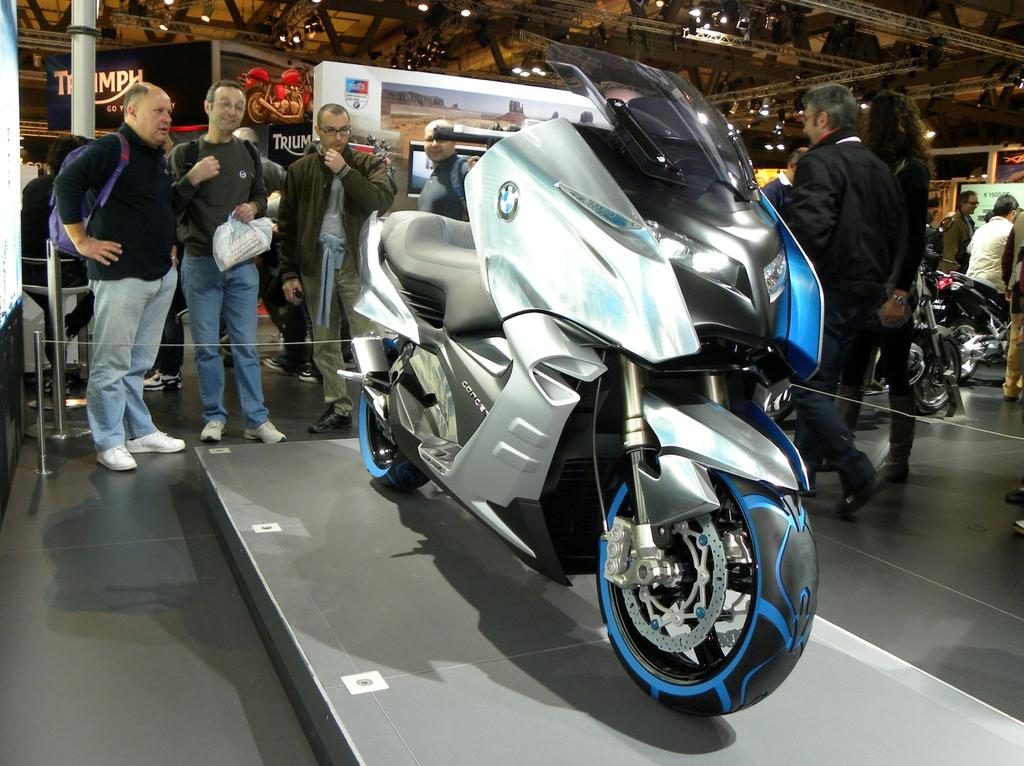What type of vehicle is in the image? There is a motor bicycle in the image. What can be seen in the background of the image? There are people standing in the background of the image. Who is sitting on the motor bicycle? There is a man sitting on the motor bicycle. Can you describe the light in the image? There is a light in the image, but its specific characteristics are not mentioned in the facts. What type of bird can be seen flying over the cemetery in the image? There is no bird or cemetery present in the image; it features a motor bicycle, people, and a man sitting on the motor bicycle. 